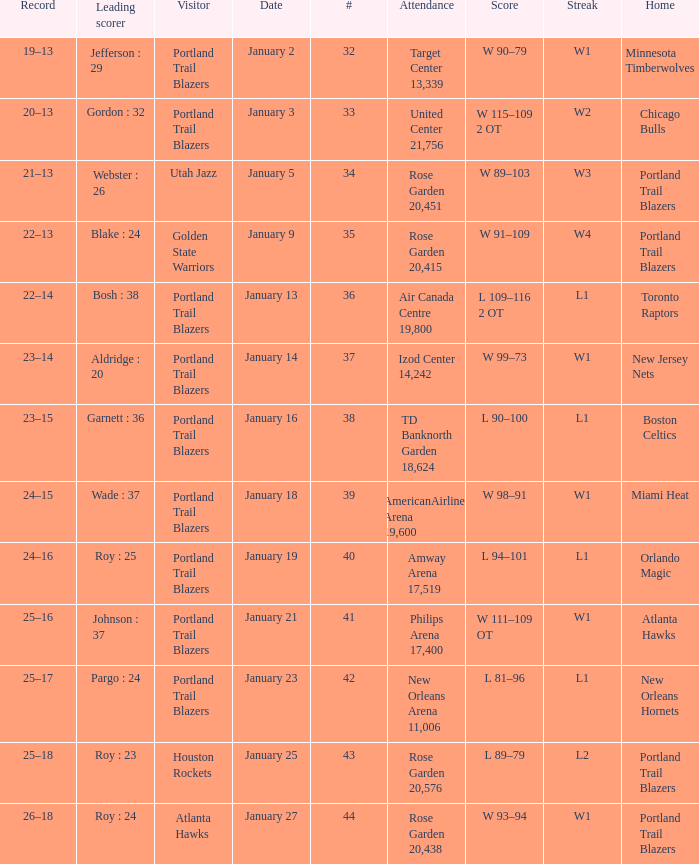What is the total number of dates where the scorer is gordon : 32 1.0. 